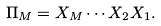<formula> <loc_0><loc_0><loc_500><loc_500>\Pi _ { M } = X _ { M } \cdots X _ { 2 } X _ { 1 } .</formula> 